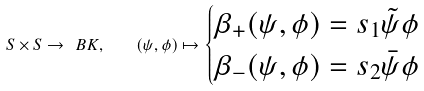<formula> <loc_0><loc_0><loc_500><loc_500>S \times S \rightarrow \ B K , \quad ( \psi , \phi ) \mapsto \begin{cases} \beta _ { + } ( \psi , \phi ) = s _ { 1 } \tilde { \psi } \phi \\ \beta _ { - } ( \psi , \phi ) = s _ { 2 } \bar { \psi } \phi \end{cases}</formula> 